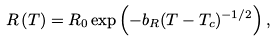<formula> <loc_0><loc_0><loc_500><loc_500>R \left ( T \right ) = R _ { 0 } \exp \left ( { - b _ { R } } ( T - T _ { c } ) ^ { - 1 / 2 } \right ) ,</formula> 